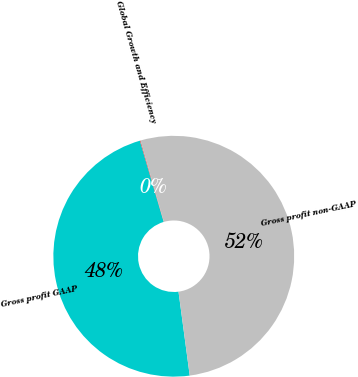Convert chart. <chart><loc_0><loc_0><loc_500><loc_500><pie_chart><fcel>Gross profit GAAP<fcel>Global Growth and Efficiency<fcel>Gross profit non-GAAP<nl><fcel>47.57%<fcel>0.1%<fcel>52.33%<nl></chart> 